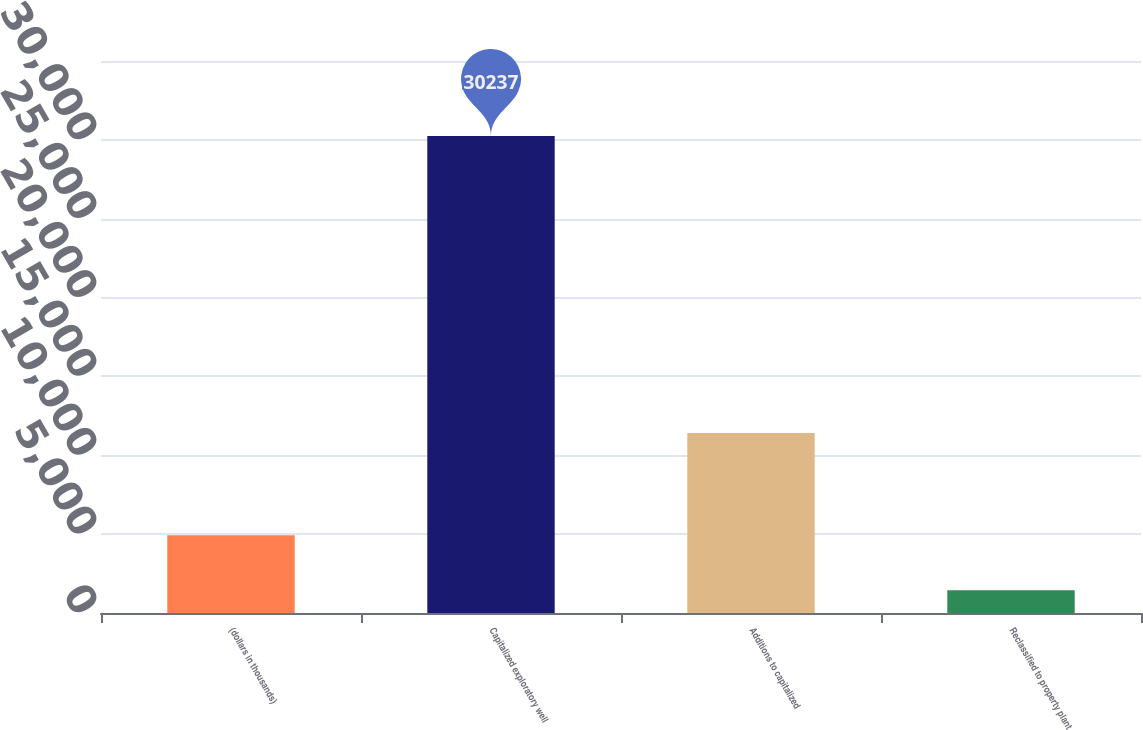Convert chart. <chart><loc_0><loc_0><loc_500><loc_500><bar_chart><fcel>(dollars in thousands)<fcel>Capitalized exploratory well<fcel>Additions to capitalized<fcel>Reclassified to property plant<nl><fcel>4928.3<fcel>30237<fcel>11409<fcel>1438<nl></chart> 